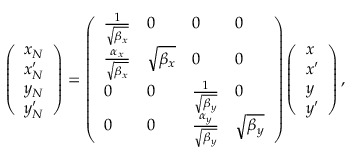<formula> <loc_0><loc_0><loc_500><loc_500>\left ( \begin{array} { l } { x _ { N } } \\ { x _ { N } ^ { \prime } } \\ { y _ { N } } \\ { y _ { N } ^ { \prime } } \end{array} \right ) = \left ( \begin{array} { l l l l } { \frac { 1 } { \sqrt { \beta _ { x } } } } & { 0 } & { 0 } & { 0 } \\ { \frac { \alpha _ { x } } { \sqrt { \beta _ { x } } } } & { \sqrt { \beta _ { x } } } & { 0 } & { 0 } \\ { 0 } & { 0 } & { \frac { 1 } { \sqrt { \beta _ { y } } } } & { 0 } \\ { 0 } & { 0 } & { \frac { \alpha _ { y } } { \sqrt { \beta _ { y } } } } & { \sqrt { \beta _ { y } } } \end{array} \right ) \left ( \begin{array} { l } { x } \\ { x ^ { \prime } } \\ { y } \\ { y ^ { \prime } } \end{array} \right ) ,</formula> 